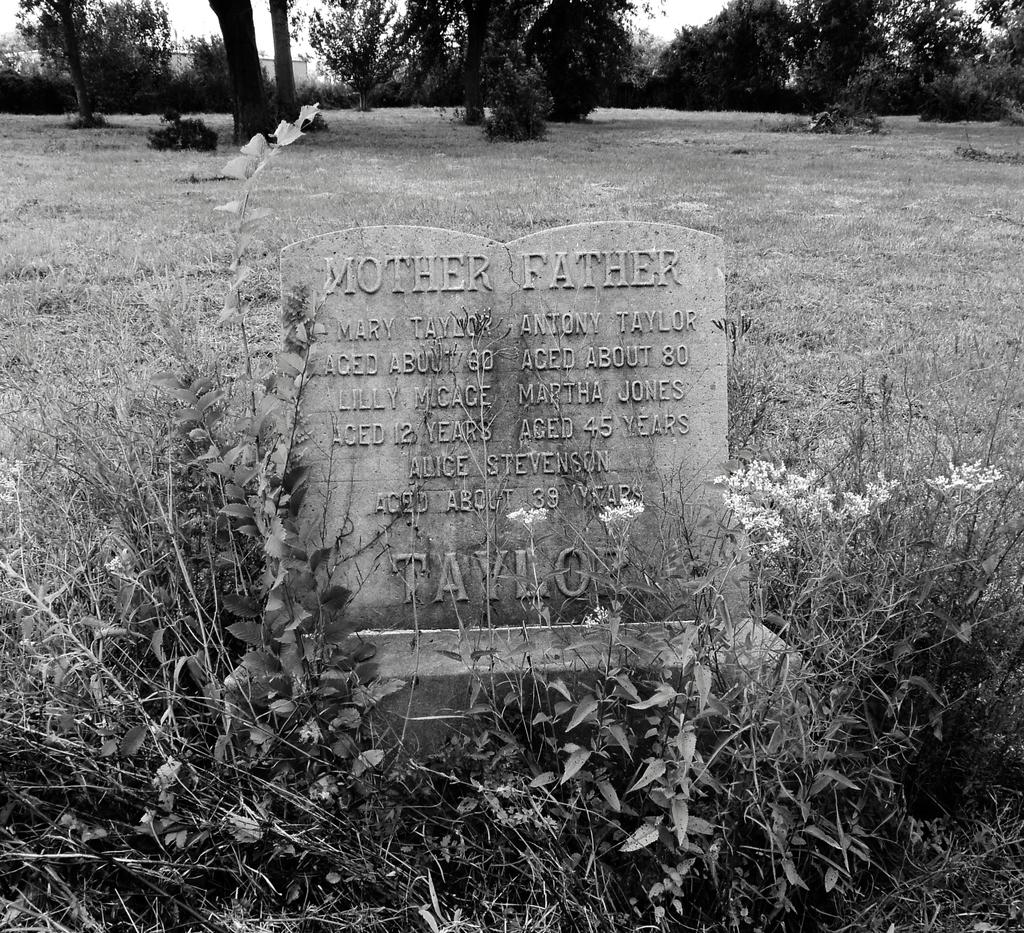What is written or depicted on the stone in the image? There is text on a stone in the image. What type of vegetation can be seen on the ground in the image? There are plants and grass on the ground in the image. What type of larger vegetation is visible in the image? There are trees visible in the image. What type of meat is hanging from the tree in the image? There is no meat present in the image; it features text on a stone, plants, grass, and trees. What kind of jewel can be seen adorning the plants in the image? There are no jewels present in the image; it features text on a stone, plants, grass, and trees. 